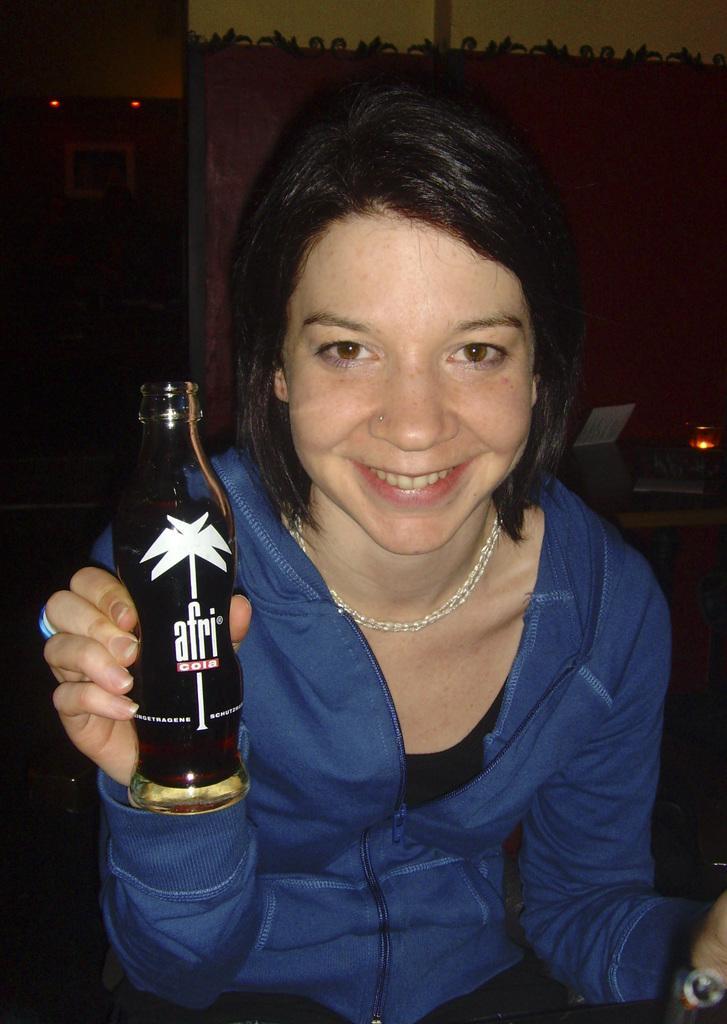Describe this image in one or two sentences. Here we can see a woman with a bottle in her hand laughing 